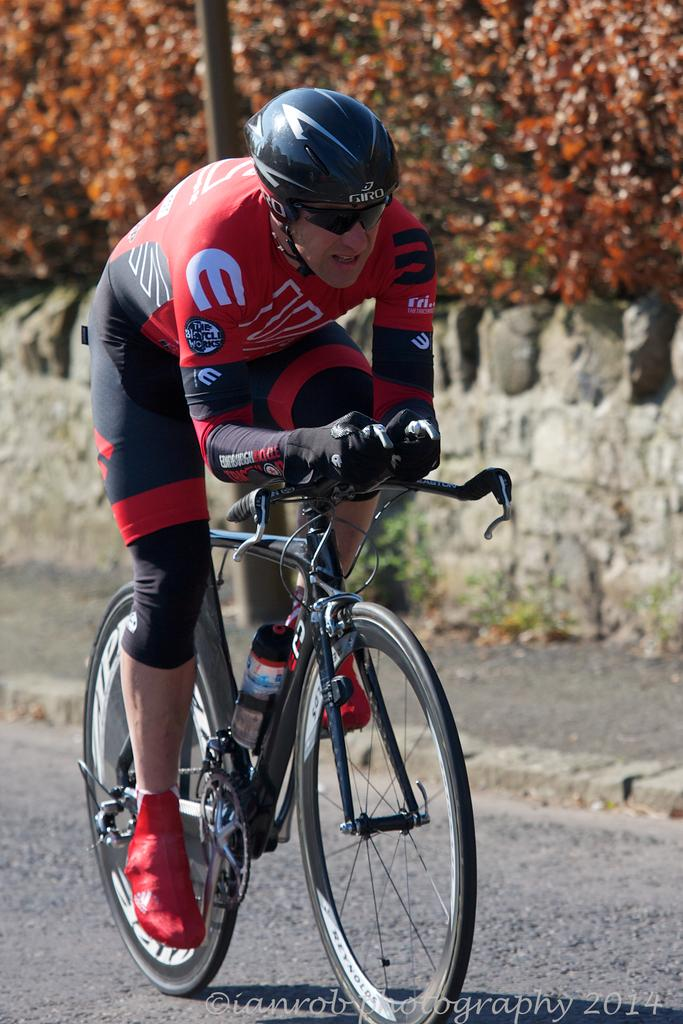What is the main subject of the image? The main subject of the image is a man. What protective gear is the man wearing? The man is wearing a helmet, goggles, gloves, and shoes. What activity is the man engaged in? The man is riding a bicycle. Where is the bicycle located? The bicycle is on the road. What can be seen in the background of the image? There is a wall, a footpath, a pole, and trees in the background of the image. What type of picture is the man holding in the image? There is no picture present in the image; the man is riding a bicycle. What stage is the man performing on in the image? There is no stage present in the image; the man is riding a bicycle on the road. 